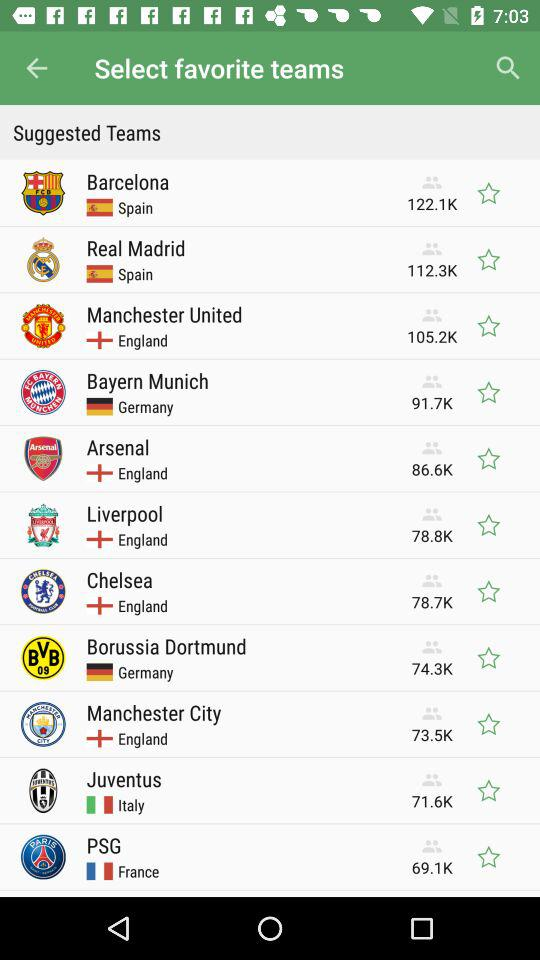How many followers are there for "Barcelona"? There are 122.1K followers. 